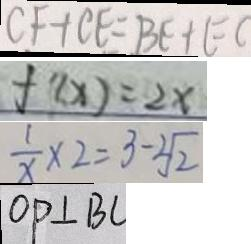Convert formula to latex. <formula><loc_0><loc_0><loc_500><loc_500>C F + C E = B E + E C 
 f ^ { \prime } ( x ) = 2 x 
 \frac { 1 } { x } \times 2 = 3 - \sqrt [ 2 ] { 2 } 
 O P \bot B C</formula> 